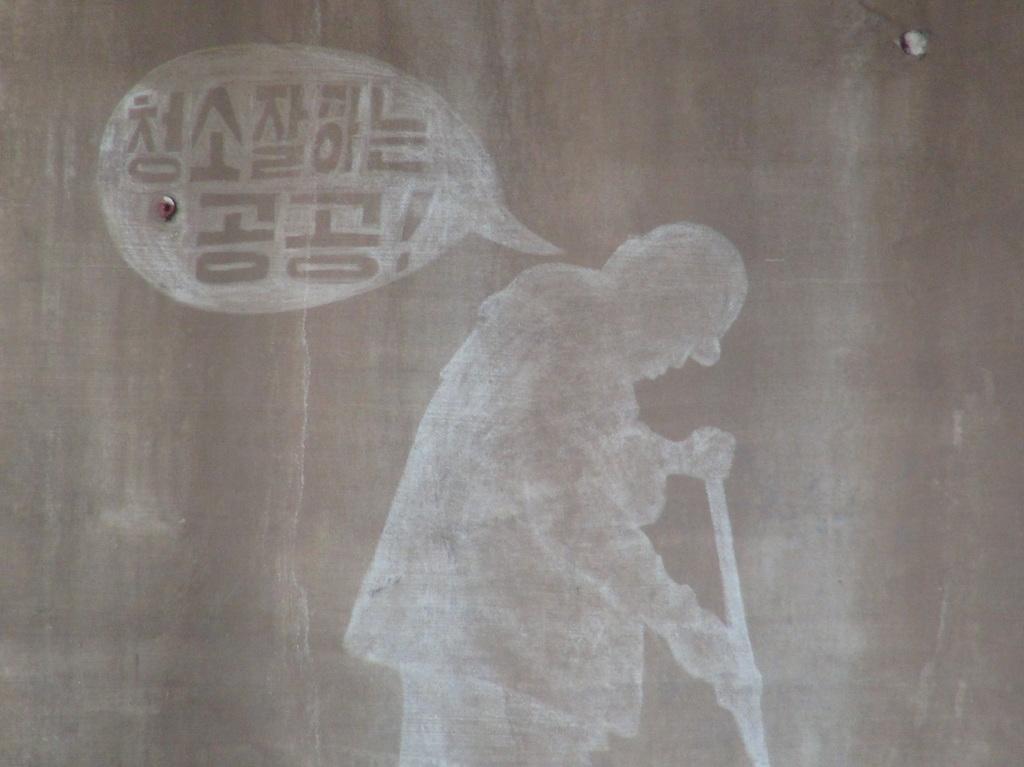In one or two sentences, can you explain what this image depicts? Sketch of a person. He is holding a stick. 